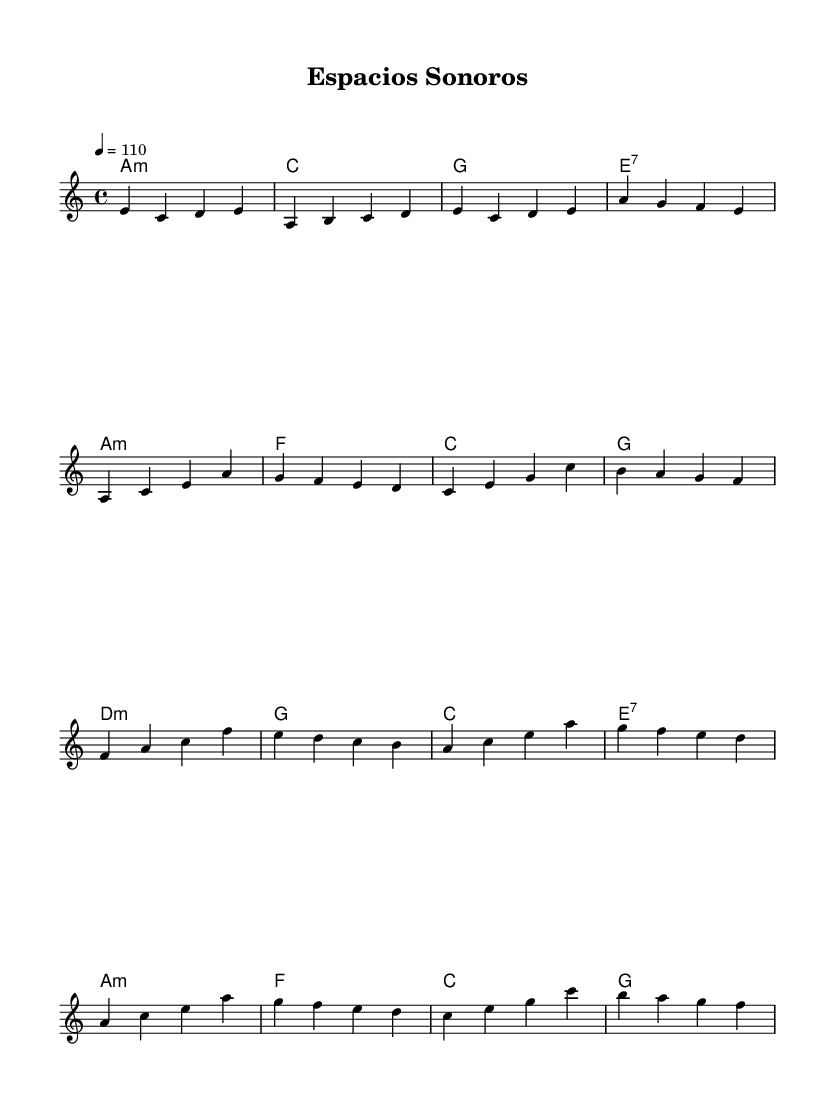What is the key signature of this music? The key signature is A minor, which has no sharps or flats.
Answer: A minor What is the time signature of the piece? The time signature is found in the beginning of the staff and is indicated by 4/4, which means four beats per measure.
Answer: 4/4 What is the tempo marking for the piece? The tempo marking, indicated by the text "4 = 110," specifies that the quarter note equals 110 beats per minute.
Answer: 110 How many measures are in the chorus section? By analyzing the music, the chorus section consists of 4 measures, as indicated by the grouping of the melody and harmonies.
Answer: 4 What is the first chord in the harmony? The first chord is indicated at the beginning of the piece and is an A minor chord (notated as "a:min").
Answer: A minor How does the pre-chorus relate to the verse structurally? The pre-chorus starts with a D minor chord and contains a different progression than the verse, which creates a build-up to the chorus. This contrast in harmony and melodic line serves to enhance the emotional intensity leading into the chorus.
Answer: Different progression What style of music does this piece represent? This piece incorporates Latin pop elements by utilizing rhythmic patterns, melodic phrasing, and a harmonic structure that are characteristic of the genre.
Answer: Latin pop 